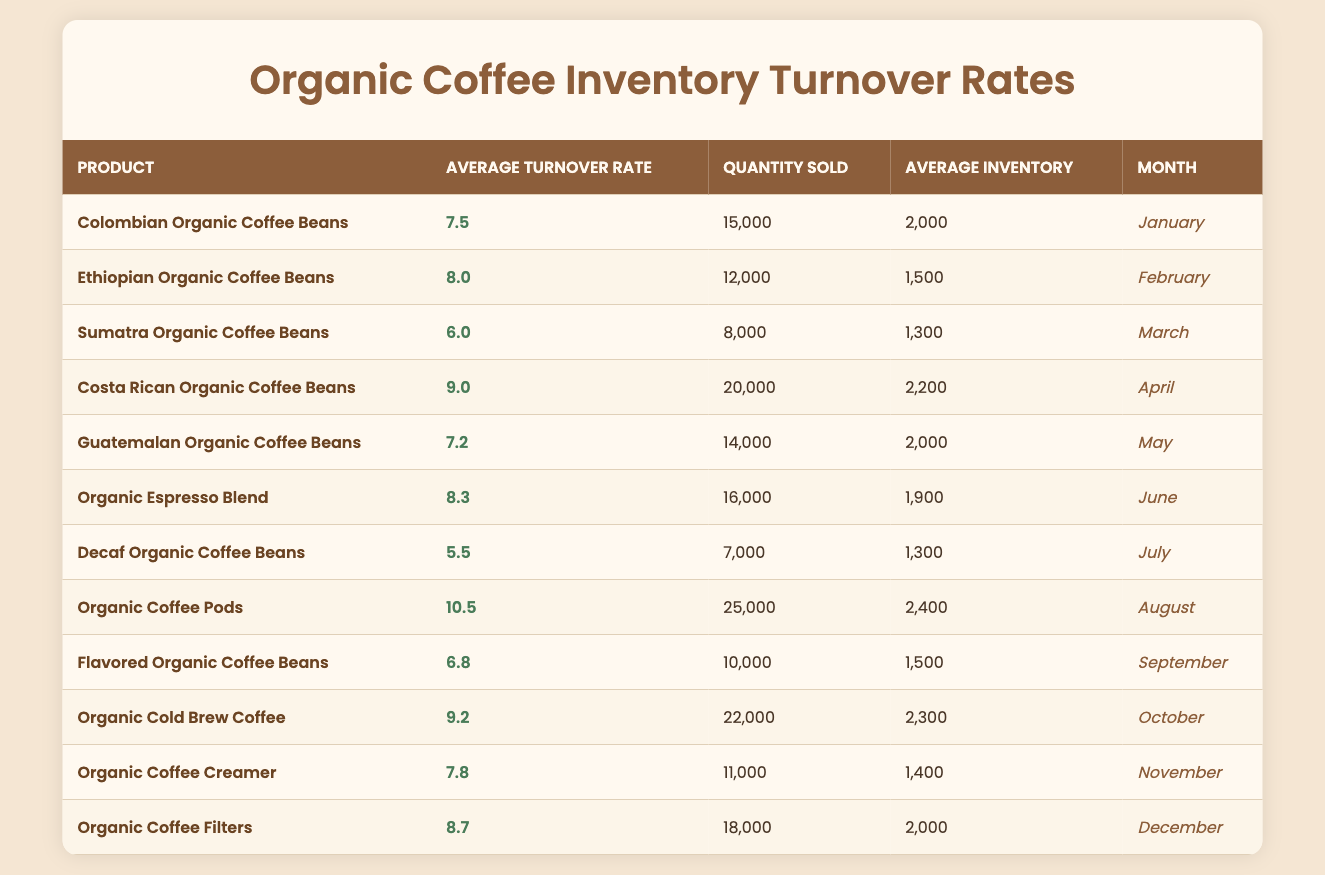What is the average turnover rate for Colombian Organic Coffee Beans? By looking at the table, the average turnover rate for Colombian Organic Coffee Beans is provided directly in the respective row, which shows a value of 7.5.
Answer: 7.5 Which product had the highest quantity sold in a month? Scanning through the table, it's clear that Organic Coffee Pods had the highest quantity sold with 25,000 units, which is more than any other product listed.
Answer: Organic Coffee Pods What is the average turnover rate of all products combined? To find the average turnover rate, add all the individual average turnover rates: (7.5 + 8.0 + 6.0 + 9.0 + 7.2 + 8.3 + 5.5 + 10.5 + 6.8 + 9.2 + 7.8 + 8.7) = 78.7, then divide by the number of products (12). The average turnover rate is 78.7/12 = 6.56.
Answer: 6.56 Were more than 20,000 units of coffee sold in October? In October, the table shows that 22,000 units of Organic Cold Brew Coffee were sold, which is indeed more than 20,000. Therefore, the statement is true.
Answer: Yes Which month had the lowest average turnover rate, and what was that rate? The month with the lowest average turnover rate can be determined by comparing values, and July shows the lowest average turnover rate of 5.5 for Decaf Organic Coffee Beans.
Answer: July, 5.5 How many products had an average turnover rate above 8 for the entire year? By inspecting the table, the products with an average turnover rate above 8 are Ethiopian Organic Coffee Beans (8.0), Organic Espresso Blend (8.3), Organic Coffee Pods (10.5), and Organic Coffee Filters (8.7). This totals to 4 products throughout the year.
Answer: 4 What is the difference in average turnover rates between the highest and lowest products? The highest average turnover rate is 10.5 (Organic Coffee Pods) while the lowest is 5.5 (Decaf Organic Coffee Beans). The difference is 10.5 - 5.5 = 5.0.
Answer: 5.0 Did any product sell fewer than 8,000 units in a month? Looking at the table, only Decaf Organic Coffee Beans sold 7,000 units in July, confirming that there was a product which sold fewer than 8,000 units.
Answer: Yes 